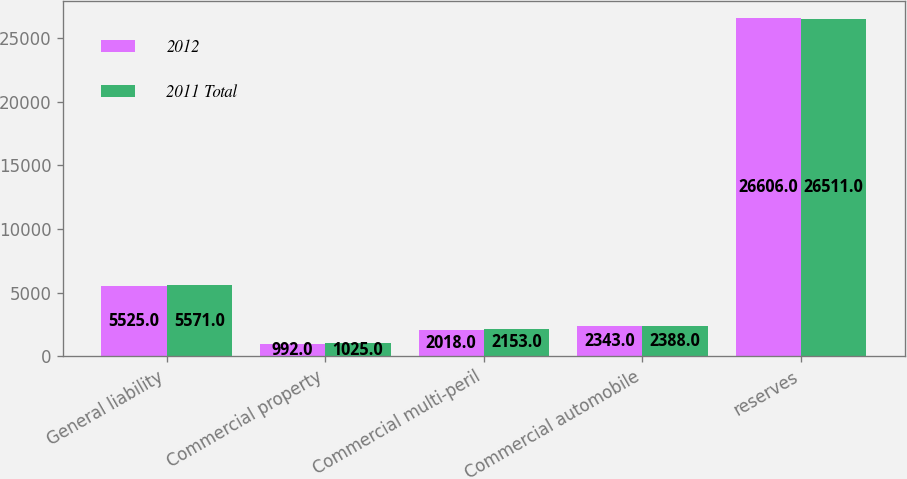Convert chart. <chart><loc_0><loc_0><loc_500><loc_500><stacked_bar_chart><ecel><fcel>General liability<fcel>Commercial property<fcel>Commercial multi-peril<fcel>Commercial automobile<fcel>reserves<nl><fcel>2012<fcel>5525<fcel>992<fcel>2018<fcel>2343<fcel>26606<nl><fcel>2011 Total<fcel>5571<fcel>1025<fcel>2153<fcel>2388<fcel>26511<nl></chart> 